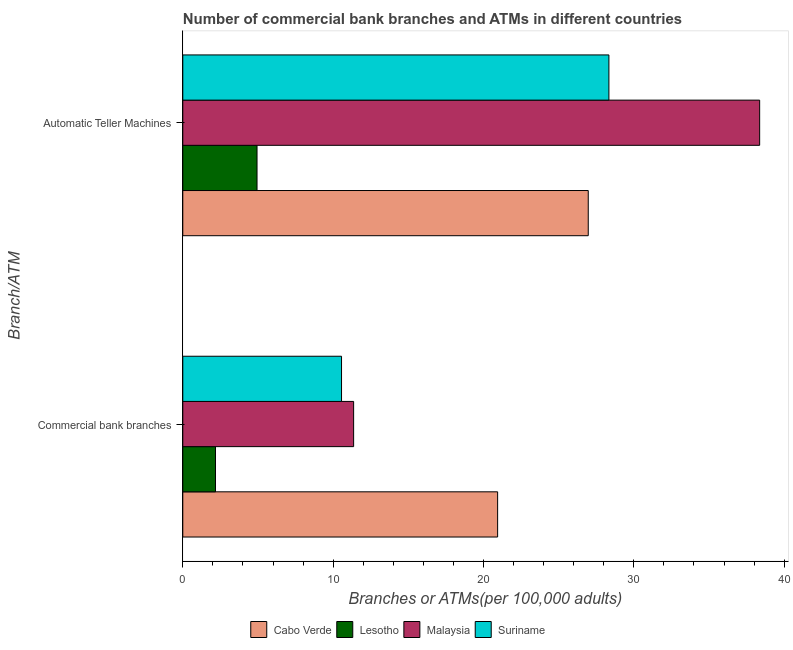How many different coloured bars are there?
Offer a very short reply. 4. How many groups of bars are there?
Your response must be concise. 2. Are the number of bars on each tick of the Y-axis equal?
Your answer should be compact. Yes. How many bars are there on the 2nd tick from the top?
Offer a very short reply. 4. How many bars are there on the 2nd tick from the bottom?
Your response must be concise. 4. What is the label of the 2nd group of bars from the top?
Keep it short and to the point. Commercial bank branches. What is the number of commercal bank branches in Suriname?
Offer a very short reply. 10.56. Across all countries, what is the maximum number of commercal bank branches?
Your response must be concise. 20.94. Across all countries, what is the minimum number of atms?
Provide a succinct answer. 4.94. In which country was the number of commercal bank branches maximum?
Ensure brevity in your answer.  Cabo Verde. In which country was the number of atms minimum?
Your response must be concise. Lesotho. What is the total number of atms in the graph?
Provide a succinct answer. 98.62. What is the difference between the number of atms in Malaysia and that in Cabo Verde?
Give a very brief answer. 11.4. What is the difference between the number of commercal bank branches in Cabo Verde and the number of atms in Malaysia?
Make the answer very short. -17.43. What is the average number of atms per country?
Your response must be concise. 24.65. What is the difference between the number of commercal bank branches and number of atms in Cabo Verde?
Your response must be concise. -6.03. What is the ratio of the number of commercal bank branches in Malaysia to that in Lesotho?
Offer a terse response. 5.22. In how many countries, is the number of commercal bank branches greater than the average number of commercal bank branches taken over all countries?
Ensure brevity in your answer.  2. What does the 4th bar from the top in Automatic Teller Machines represents?
Provide a short and direct response. Cabo Verde. What does the 1st bar from the bottom in Commercial bank branches represents?
Provide a short and direct response. Cabo Verde. What is the difference between two consecutive major ticks on the X-axis?
Provide a succinct answer. 10. Where does the legend appear in the graph?
Your answer should be compact. Bottom center. What is the title of the graph?
Your answer should be compact. Number of commercial bank branches and ATMs in different countries. What is the label or title of the X-axis?
Your response must be concise. Branches or ATMs(per 100,0 adults). What is the label or title of the Y-axis?
Make the answer very short. Branch/ATM. What is the Branches or ATMs(per 100,000 adults) in Cabo Verde in Commercial bank branches?
Provide a succinct answer. 20.94. What is the Branches or ATMs(per 100,000 adults) in Lesotho in Commercial bank branches?
Make the answer very short. 2.18. What is the Branches or ATMs(per 100,000 adults) of Malaysia in Commercial bank branches?
Give a very brief answer. 11.36. What is the Branches or ATMs(per 100,000 adults) in Suriname in Commercial bank branches?
Offer a terse response. 10.56. What is the Branches or ATMs(per 100,000 adults) in Cabo Verde in Automatic Teller Machines?
Provide a short and direct response. 26.97. What is the Branches or ATMs(per 100,000 adults) of Lesotho in Automatic Teller Machines?
Give a very brief answer. 4.94. What is the Branches or ATMs(per 100,000 adults) of Malaysia in Automatic Teller Machines?
Ensure brevity in your answer.  38.37. What is the Branches or ATMs(per 100,000 adults) in Suriname in Automatic Teller Machines?
Ensure brevity in your answer.  28.34. Across all Branch/ATM, what is the maximum Branches or ATMs(per 100,000 adults) of Cabo Verde?
Give a very brief answer. 26.97. Across all Branch/ATM, what is the maximum Branches or ATMs(per 100,000 adults) in Lesotho?
Your response must be concise. 4.94. Across all Branch/ATM, what is the maximum Branches or ATMs(per 100,000 adults) in Malaysia?
Make the answer very short. 38.37. Across all Branch/ATM, what is the maximum Branches or ATMs(per 100,000 adults) in Suriname?
Make the answer very short. 28.34. Across all Branch/ATM, what is the minimum Branches or ATMs(per 100,000 adults) in Cabo Verde?
Ensure brevity in your answer.  20.94. Across all Branch/ATM, what is the minimum Branches or ATMs(per 100,000 adults) of Lesotho?
Keep it short and to the point. 2.18. Across all Branch/ATM, what is the minimum Branches or ATMs(per 100,000 adults) in Malaysia?
Provide a succinct answer. 11.36. Across all Branch/ATM, what is the minimum Branches or ATMs(per 100,000 adults) of Suriname?
Your response must be concise. 10.56. What is the total Branches or ATMs(per 100,000 adults) of Cabo Verde in the graph?
Your answer should be compact. 47.91. What is the total Branches or ATMs(per 100,000 adults) of Lesotho in the graph?
Offer a very short reply. 7.11. What is the total Branches or ATMs(per 100,000 adults) in Malaysia in the graph?
Give a very brief answer. 49.73. What is the total Branches or ATMs(per 100,000 adults) in Suriname in the graph?
Offer a terse response. 38.9. What is the difference between the Branches or ATMs(per 100,000 adults) in Cabo Verde in Commercial bank branches and that in Automatic Teller Machines?
Offer a very short reply. -6.03. What is the difference between the Branches or ATMs(per 100,000 adults) of Lesotho in Commercial bank branches and that in Automatic Teller Machines?
Offer a very short reply. -2.76. What is the difference between the Branches or ATMs(per 100,000 adults) in Malaysia in Commercial bank branches and that in Automatic Teller Machines?
Keep it short and to the point. -27.01. What is the difference between the Branches or ATMs(per 100,000 adults) in Suriname in Commercial bank branches and that in Automatic Teller Machines?
Offer a very short reply. -17.78. What is the difference between the Branches or ATMs(per 100,000 adults) of Cabo Verde in Commercial bank branches and the Branches or ATMs(per 100,000 adults) of Lesotho in Automatic Teller Machines?
Your answer should be very brief. 16. What is the difference between the Branches or ATMs(per 100,000 adults) in Cabo Verde in Commercial bank branches and the Branches or ATMs(per 100,000 adults) in Malaysia in Automatic Teller Machines?
Provide a short and direct response. -17.43. What is the difference between the Branches or ATMs(per 100,000 adults) in Cabo Verde in Commercial bank branches and the Branches or ATMs(per 100,000 adults) in Suriname in Automatic Teller Machines?
Ensure brevity in your answer.  -7.4. What is the difference between the Branches or ATMs(per 100,000 adults) of Lesotho in Commercial bank branches and the Branches or ATMs(per 100,000 adults) of Malaysia in Automatic Teller Machines?
Your response must be concise. -36.19. What is the difference between the Branches or ATMs(per 100,000 adults) in Lesotho in Commercial bank branches and the Branches or ATMs(per 100,000 adults) in Suriname in Automatic Teller Machines?
Provide a short and direct response. -26.17. What is the difference between the Branches or ATMs(per 100,000 adults) in Malaysia in Commercial bank branches and the Branches or ATMs(per 100,000 adults) in Suriname in Automatic Teller Machines?
Ensure brevity in your answer.  -16.98. What is the average Branches or ATMs(per 100,000 adults) of Cabo Verde per Branch/ATM?
Offer a very short reply. 23.95. What is the average Branches or ATMs(per 100,000 adults) of Lesotho per Branch/ATM?
Give a very brief answer. 3.56. What is the average Branches or ATMs(per 100,000 adults) of Malaysia per Branch/ATM?
Provide a succinct answer. 24.87. What is the average Branches or ATMs(per 100,000 adults) in Suriname per Branch/ATM?
Provide a succinct answer. 19.45. What is the difference between the Branches or ATMs(per 100,000 adults) in Cabo Verde and Branches or ATMs(per 100,000 adults) in Lesotho in Commercial bank branches?
Your answer should be very brief. 18.76. What is the difference between the Branches or ATMs(per 100,000 adults) of Cabo Verde and Branches or ATMs(per 100,000 adults) of Malaysia in Commercial bank branches?
Make the answer very short. 9.58. What is the difference between the Branches or ATMs(per 100,000 adults) of Cabo Verde and Branches or ATMs(per 100,000 adults) of Suriname in Commercial bank branches?
Provide a succinct answer. 10.38. What is the difference between the Branches or ATMs(per 100,000 adults) in Lesotho and Branches or ATMs(per 100,000 adults) in Malaysia in Commercial bank branches?
Keep it short and to the point. -9.19. What is the difference between the Branches or ATMs(per 100,000 adults) in Lesotho and Branches or ATMs(per 100,000 adults) in Suriname in Commercial bank branches?
Your response must be concise. -8.38. What is the difference between the Branches or ATMs(per 100,000 adults) of Malaysia and Branches or ATMs(per 100,000 adults) of Suriname in Commercial bank branches?
Provide a short and direct response. 0.8. What is the difference between the Branches or ATMs(per 100,000 adults) in Cabo Verde and Branches or ATMs(per 100,000 adults) in Lesotho in Automatic Teller Machines?
Make the answer very short. 22.03. What is the difference between the Branches or ATMs(per 100,000 adults) in Cabo Verde and Branches or ATMs(per 100,000 adults) in Malaysia in Automatic Teller Machines?
Your answer should be compact. -11.4. What is the difference between the Branches or ATMs(per 100,000 adults) in Cabo Verde and Branches or ATMs(per 100,000 adults) in Suriname in Automatic Teller Machines?
Your answer should be compact. -1.37. What is the difference between the Branches or ATMs(per 100,000 adults) in Lesotho and Branches or ATMs(per 100,000 adults) in Malaysia in Automatic Teller Machines?
Provide a succinct answer. -33.43. What is the difference between the Branches or ATMs(per 100,000 adults) of Lesotho and Branches or ATMs(per 100,000 adults) of Suriname in Automatic Teller Machines?
Provide a short and direct response. -23.4. What is the difference between the Branches or ATMs(per 100,000 adults) of Malaysia and Branches or ATMs(per 100,000 adults) of Suriname in Automatic Teller Machines?
Your response must be concise. 10.03. What is the ratio of the Branches or ATMs(per 100,000 adults) in Cabo Verde in Commercial bank branches to that in Automatic Teller Machines?
Provide a short and direct response. 0.78. What is the ratio of the Branches or ATMs(per 100,000 adults) in Lesotho in Commercial bank branches to that in Automatic Teller Machines?
Keep it short and to the point. 0.44. What is the ratio of the Branches or ATMs(per 100,000 adults) in Malaysia in Commercial bank branches to that in Automatic Teller Machines?
Make the answer very short. 0.3. What is the ratio of the Branches or ATMs(per 100,000 adults) of Suriname in Commercial bank branches to that in Automatic Teller Machines?
Keep it short and to the point. 0.37. What is the difference between the highest and the second highest Branches or ATMs(per 100,000 adults) in Cabo Verde?
Keep it short and to the point. 6.03. What is the difference between the highest and the second highest Branches or ATMs(per 100,000 adults) in Lesotho?
Offer a terse response. 2.76. What is the difference between the highest and the second highest Branches or ATMs(per 100,000 adults) of Malaysia?
Your answer should be compact. 27.01. What is the difference between the highest and the second highest Branches or ATMs(per 100,000 adults) of Suriname?
Provide a short and direct response. 17.78. What is the difference between the highest and the lowest Branches or ATMs(per 100,000 adults) of Cabo Verde?
Make the answer very short. 6.03. What is the difference between the highest and the lowest Branches or ATMs(per 100,000 adults) of Lesotho?
Offer a very short reply. 2.76. What is the difference between the highest and the lowest Branches or ATMs(per 100,000 adults) of Malaysia?
Your answer should be very brief. 27.01. What is the difference between the highest and the lowest Branches or ATMs(per 100,000 adults) in Suriname?
Provide a succinct answer. 17.78. 